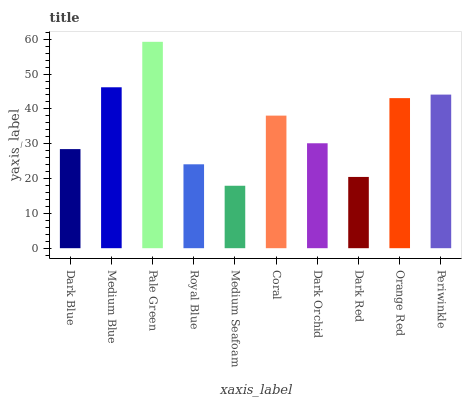Is Medium Seafoam the minimum?
Answer yes or no. Yes. Is Pale Green the maximum?
Answer yes or no. Yes. Is Medium Blue the minimum?
Answer yes or no. No. Is Medium Blue the maximum?
Answer yes or no. No. Is Medium Blue greater than Dark Blue?
Answer yes or no. Yes. Is Dark Blue less than Medium Blue?
Answer yes or no. Yes. Is Dark Blue greater than Medium Blue?
Answer yes or no. No. Is Medium Blue less than Dark Blue?
Answer yes or no. No. Is Coral the high median?
Answer yes or no. Yes. Is Dark Orchid the low median?
Answer yes or no. Yes. Is Orange Red the high median?
Answer yes or no. No. Is Coral the low median?
Answer yes or no. No. 